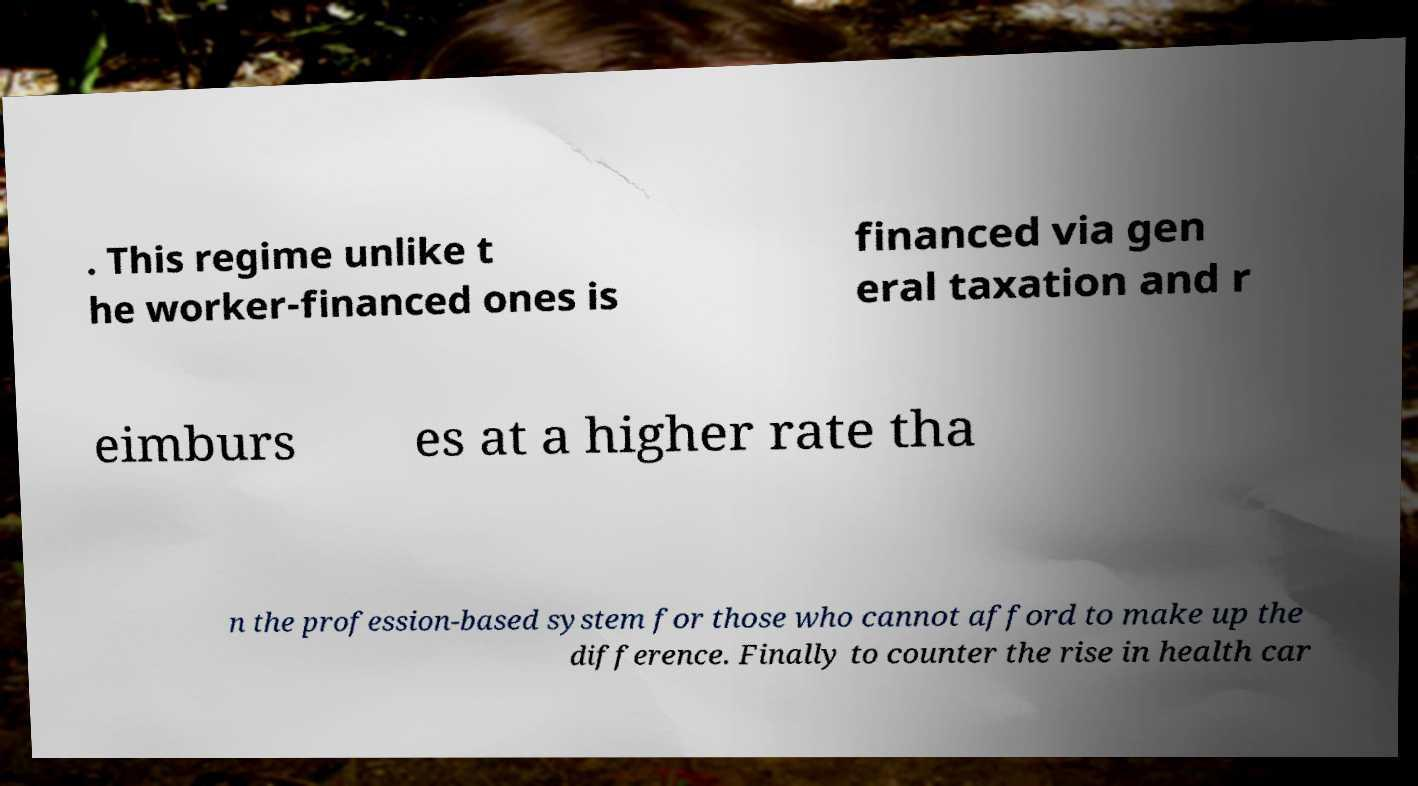I need the written content from this picture converted into text. Can you do that? . This regime unlike t he worker-financed ones is financed via gen eral taxation and r eimburs es at a higher rate tha n the profession-based system for those who cannot afford to make up the difference. Finally to counter the rise in health car 